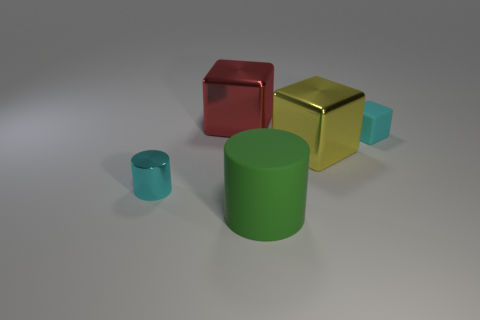Do the large cylinder and the big block on the right side of the red cube have the same color?
Your answer should be compact. No. There is a red block that is the same size as the rubber cylinder; what is it made of?
Ensure brevity in your answer.  Metal. Is the number of cyan cylinders behind the large red cube less than the number of big red cubes that are on the left side of the cyan block?
Your answer should be very brief. Yes. What is the shape of the tiny cyan object behind the small object on the left side of the cyan cube?
Provide a short and direct response. Cube. Are any large red shiny cubes visible?
Provide a succinct answer. Yes. The large cube that is on the right side of the large matte cylinder is what color?
Keep it short and to the point. Yellow. There is a small cube that is the same color as the tiny metal cylinder; what is its material?
Your answer should be very brief. Rubber. There is a red cube; are there any yellow things behind it?
Keep it short and to the point. No. Is the number of cyan metallic cylinders greater than the number of large things?
Your answer should be compact. No. The metallic cube that is behind the cyan thing right of the cylinder behind the large green rubber cylinder is what color?
Offer a terse response. Red. 